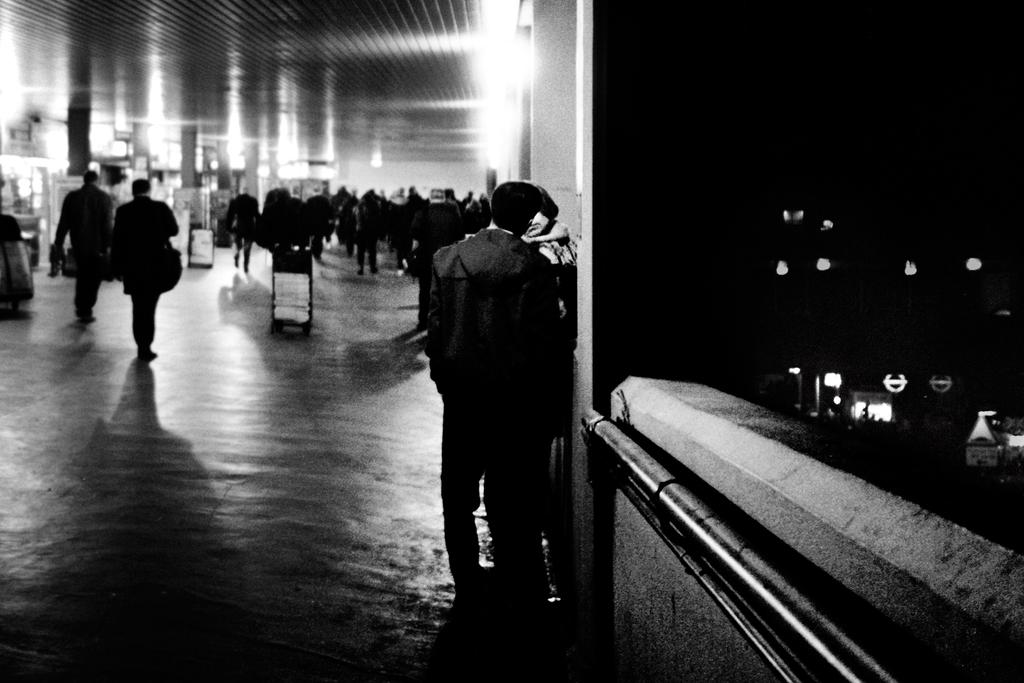Who or what can be seen in the image? There are people visible in the image. What else is present in the image besides people? There are boats and pillars visible in the image. How can you describe the lighting conditions in the image? There is darkness on the right side of the image, but there are lights visible as well. How many cats are sitting on the dirt in the image? There are no cats or dirt present in the image. 